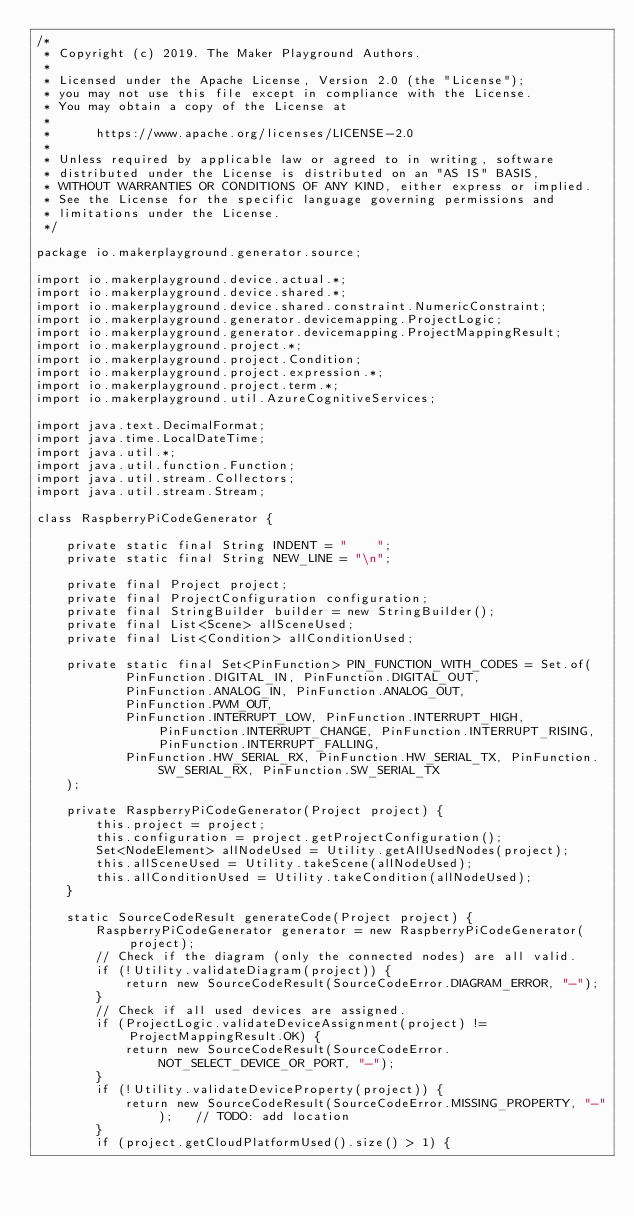<code> <loc_0><loc_0><loc_500><loc_500><_Java_>/*
 * Copyright (c) 2019. The Maker Playground Authors.
 *
 * Licensed under the Apache License, Version 2.0 (the "License");
 * you may not use this file except in compliance with the License.
 * You may obtain a copy of the License at
 *
 *      https://www.apache.org/licenses/LICENSE-2.0
 *
 * Unless required by applicable law or agreed to in writing, software
 * distributed under the License is distributed on an "AS IS" BASIS,
 * WITHOUT WARRANTIES OR CONDITIONS OF ANY KIND, either express or implied.
 * See the License for the specific language governing permissions and
 * limitations under the License.
 */

package io.makerplayground.generator.source;

import io.makerplayground.device.actual.*;
import io.makerplayground.device.shared.*;
import io.makerplayground.device.shared.constraint.NumericConstraint;
import io.makerplayground.generator.devicemapping.ProjectLogic;
import io.makerplayground.generator.devicemapping.ProjectMappingResult;
import io.makerplayground.project.*;
import io.makerplayground.project.Condition;
import io.makerplayground.project.expression.*;
import io.makerplayground.project.term.*;
import io.makerplayground.util.AzureCognitiveServices;

import java.text.DecimalFormat;
import java.time.LocalDateTime;
import java.util.*;
import java.util.function.Function;
import java.util.stream.Collectors;
import java.util.stream.Stream;

class RaspberryPiCodeGenerator {

    private static final String INDENT = "    ";
    private static final String NEW_LINE = "\n";

    private final Project project;
    private final ProjectConfiguration configuration;
    private final StringBuilder builder = new StringBuilder();
    private final List<Scene> allSceneUsed;
    private final List<Condition> allConditionUsed;

    private static final Set<PinFunction> PIN_FUNCTION_WITH_CODES = Set.of(
            PinFunction.DIGITAL_IN, PinFunction.DIGITAL_OUT,
            PinFunction.ANALOG_IN, PinFunction.ANALOG_OUT,
            PinFunction.PWM_OUT,
            PinFunction.INTERRUPT_LOW, PinFunction.INTERRUPT_HIGH, PinFunction.INTERRUPT_CHANGE, PinFunction.INTERRUPT_RISING, PinFunction.INTERRUPT_FALLING,
            PinFunction.HW_SERIAL_RX, PinFunction.HW_SERIAL_TX, PinFunction.SW_SERIAL_RX, PinFunction.SW_SERIAL_TX
    );

    private RaspberryPiCodeGenerator(Project project) {
        this.project = project;
        this.configuration = project.getProjectConfiguration();
        Set<NodeElement> allNodeUsed = Utility.getAllUsedNodes(project);
        this.allSceneUsed = Utility.takeScene(allNodeUsed);
        this.allConditionUsed = Utility.takeCondition(allNodeUsed);
    }

    static SourceCodeResult generateCode(Project project) {
        RaspberryPiCodeGenerator generator = new RaspberryPiCodeGenerator(project);
        // Check if the diagram (only the connected nodes) are all valid.
        if (!Utility.validateDiagram(project)) {
            return new SourceCodeResult(SourceCodeError.DIAGRAM_ERROR, "-");
        }
        // Check if all used devices are assigned.
        if (ProjectLogic.validateDeviceAssignment(project) != ProjectMappingResult.OK) {
            return new SourceCodeResult(SourceCodeError.NOT_SELECT_DEVICE_OR_PORT, "-");
        }
        if (!Utility.validateDeviceProperty(project)) {
            return new SourceCodeResult(SourceCodeError.MISSING_PROPERTY, "-");   // TODO: add location
        }
        if (project.getCloudPlatformUsed().size() > 1) {</code> 